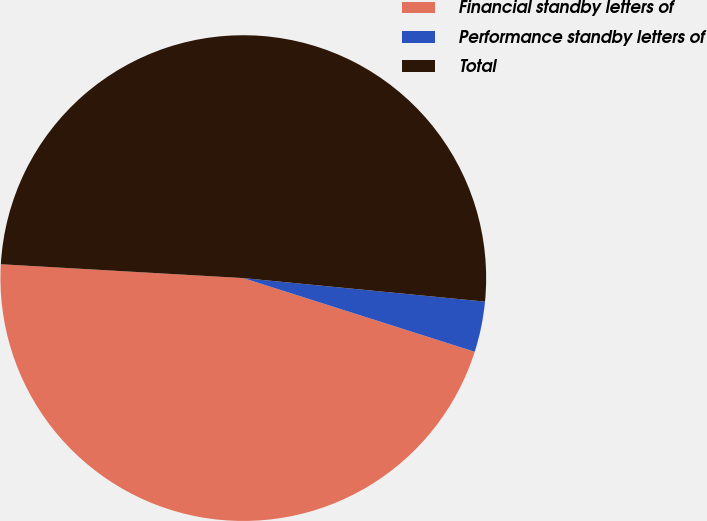<chart> <loc_0><loc_0><loc_500><loc_500><pie_chart><fcel>Financial standby letters of<fcel>Performance standby letters of<fcel>Total<nl><fcel>46.0%<fcel>3.36%<fcel>50.63%<nl></chart> 